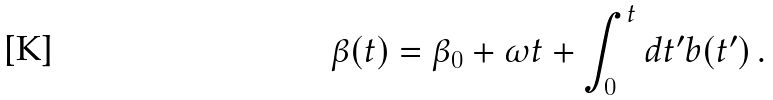Convert formula to latex. <formula><loc_0><loc_0><loc_500><loc_500>\beta ( t ) = \beta _ { 0 } + \omega t + \int _ { 0 } ^ { t } d t ^ { \prime } b ( t ^ { \prime } ) \, .</formula> 